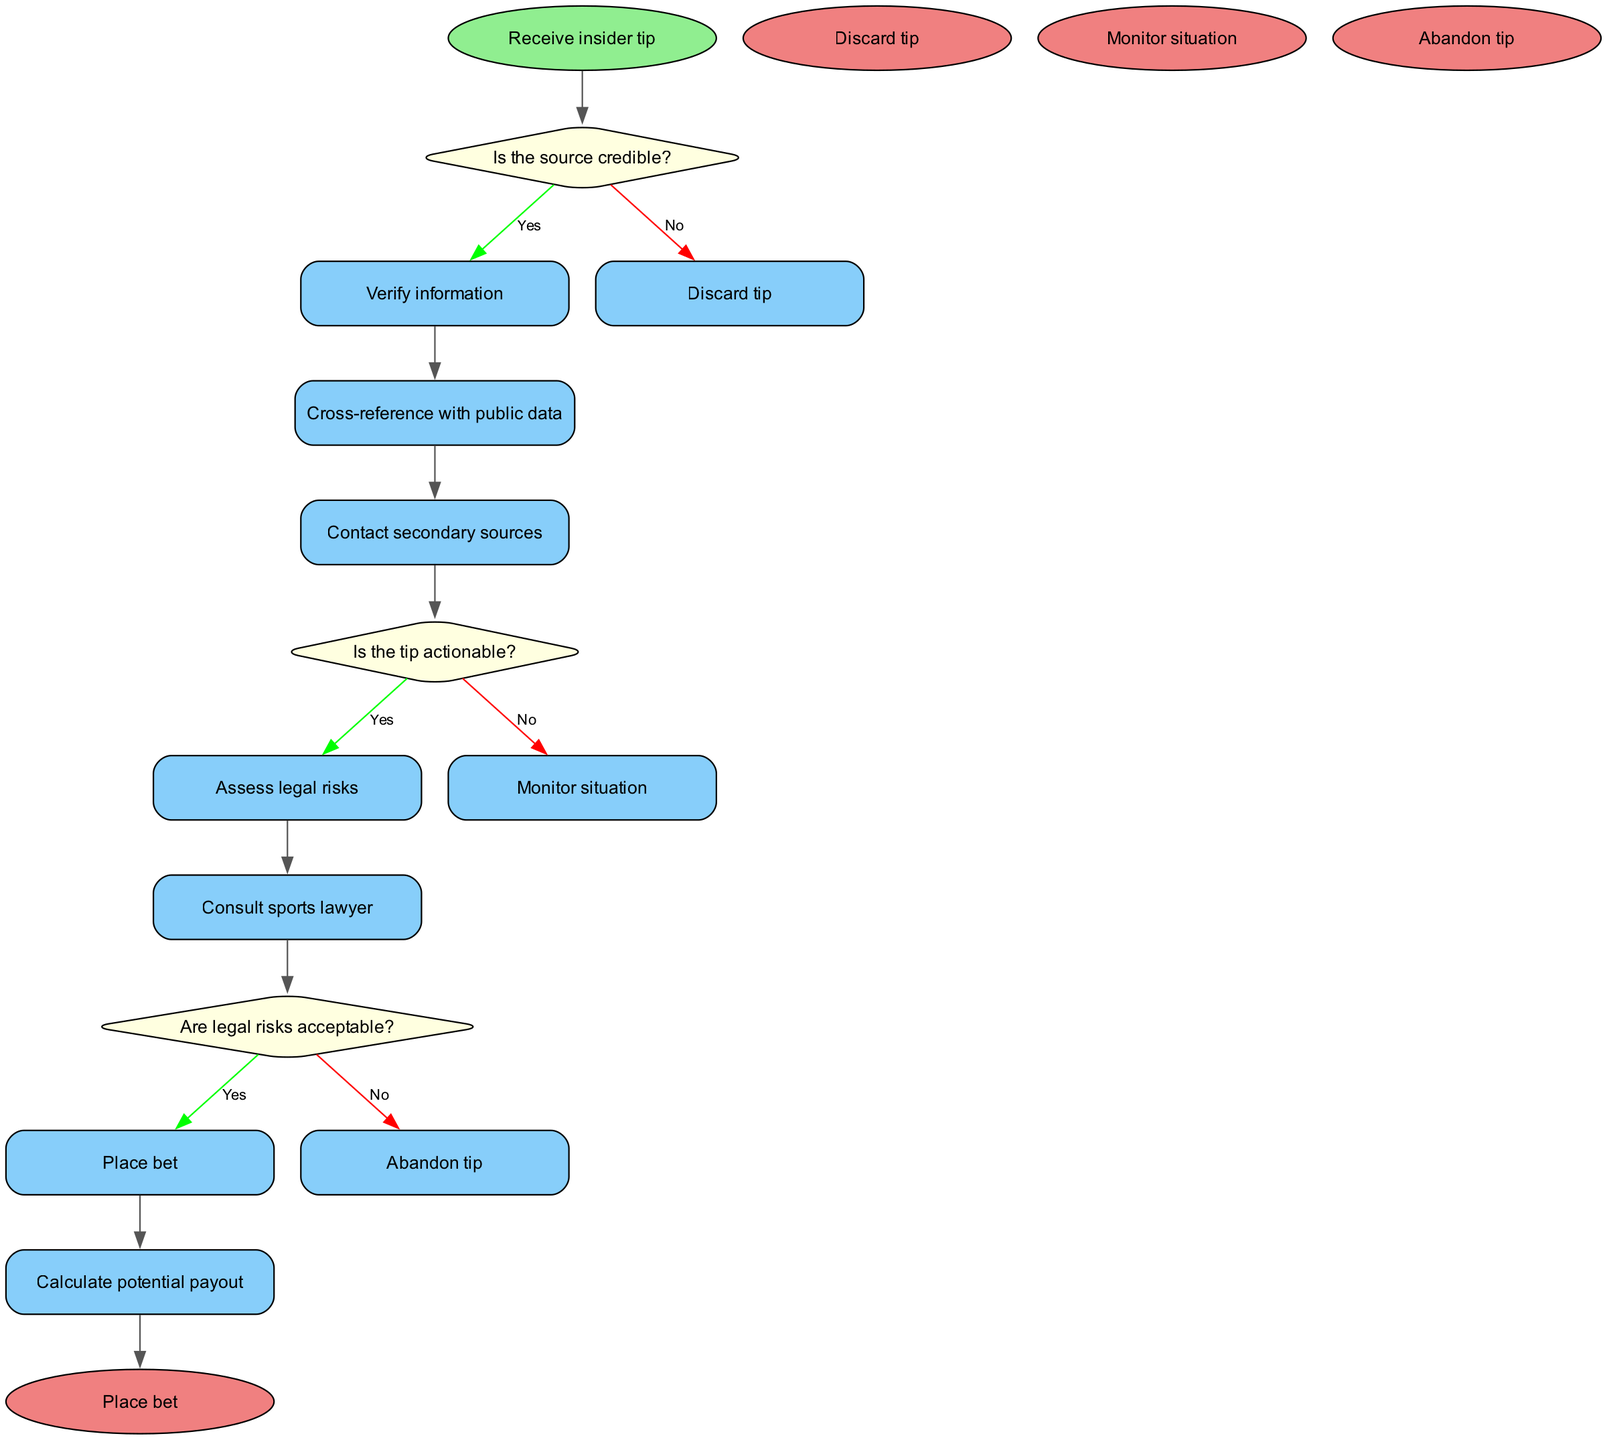What is the starting point of the flowchart? The flowchart begins with the node labeled "Receive insider tip". This represents the initial action taken in the process.
Answer: Receive insider tip How many decision nodes are present in the flowchart? There are three decision nodes where choices are made regarding the credibility, actionability, and legal risks associated with the tip.
Answer: 3 What action is taken if the source is not credible? If the source is deemed not credible, the flowchart indicates to "Discard tip", which represents a direct action to take in response to the decision.
Answer: Discard tip What follows after verifying the information from a credible source? After verifying the information, the next step is to "Cross-reference with public data", which is a process that follows the successful verification of the tip.
Answer: Cross-reference with public data What happens if the legal risks are unacceptable? If the legal risks associated with the insider information are found to be unacceptable, the flowchart instructs to "Abandon tip", indicating a decision to withdraw from any potential action.
Answer: Abandon tip How is the flow of the diagram structured? The flowchart is structured in a linear format, starting with the initial tip and branching out through decisions that lead to different process actions and end nodes.
Answer: Linear format What does the node "Place bet" represent in the flowchart? The node "Place bet" signifies the final action taken when all decisions leading up to that node are resolved positively regarding credibility, actionability, and legal risks.
Answer: Place bet What is the consequence of the tip being unverified? If the tip remains unverified, the flowchart does not lead to any actionable steps and suggests to "Monitor situation" as a precautionary measure.
Answer: Monitor situation 